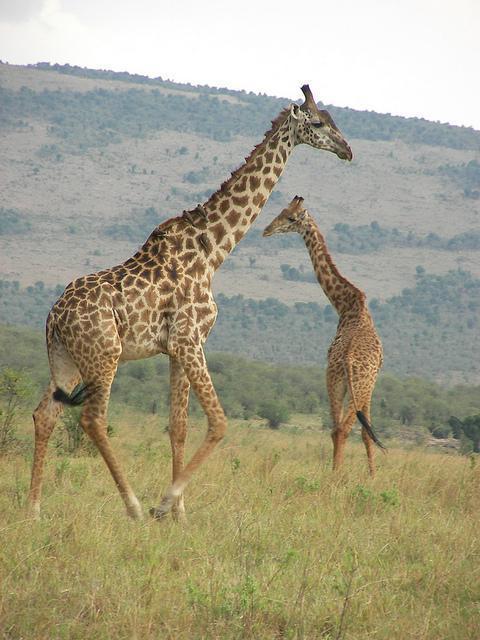How many baby giraffes are in the field?
Give a very brief answer. 1. How many giraffes are standing?
Give a very brief answer. 2. How many giraffes are there?
Give a very brief answer. 2. How many giraffes are in the photo?
Give a very brief answer. 2. 